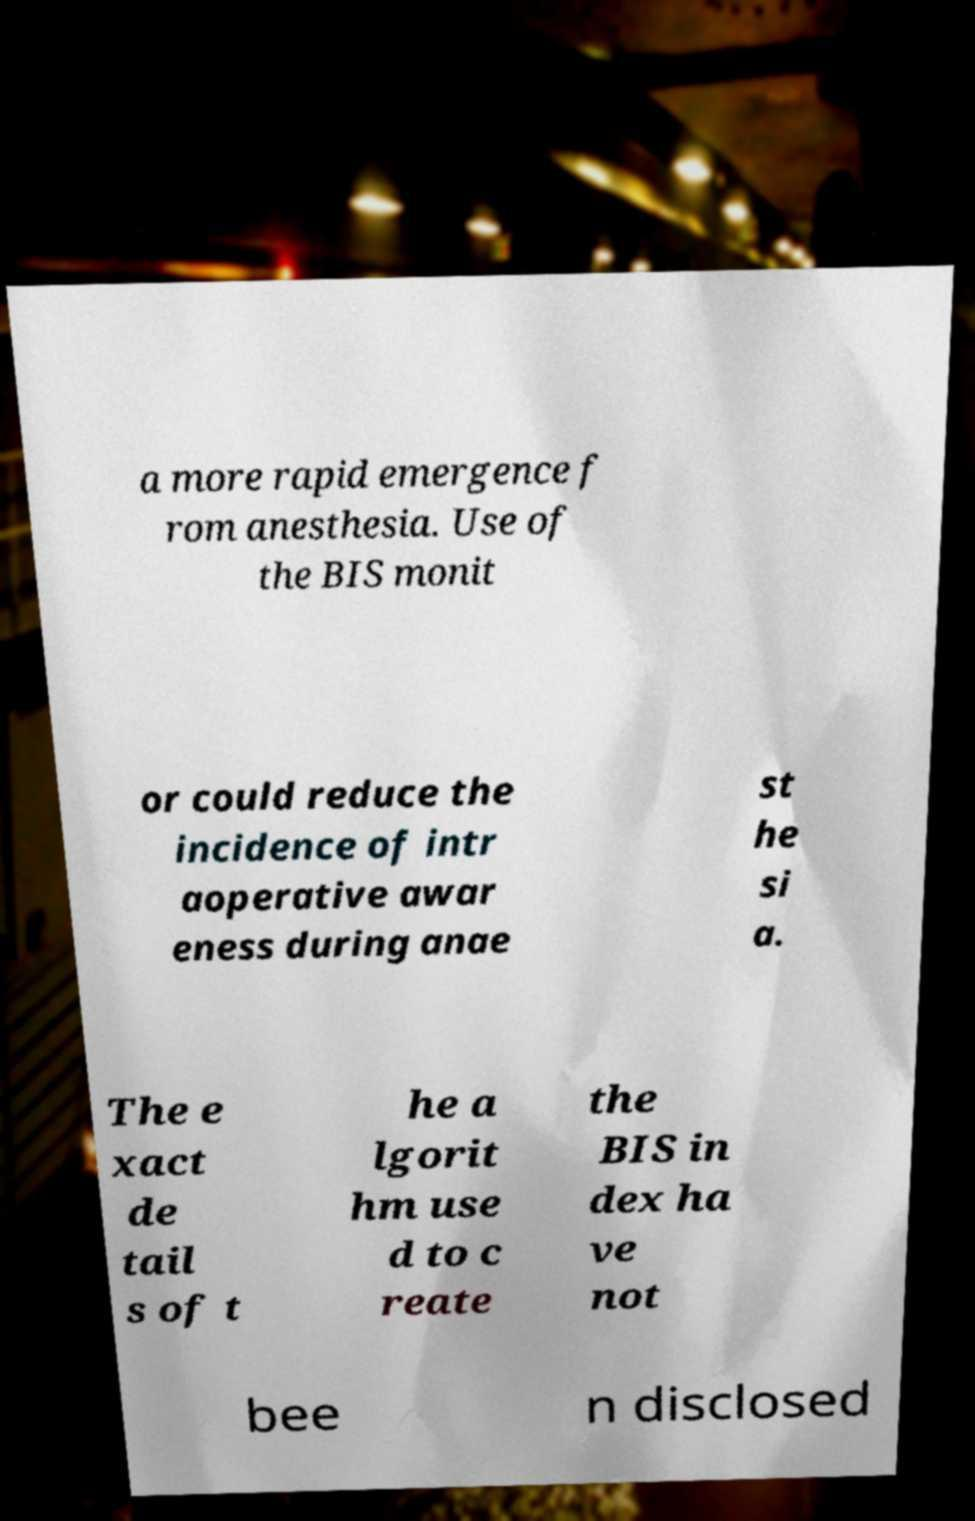What messages or text are displayed in this image? I need them in a readable, typed format. a more rapid emergence f rom anesthesia. Use of the BIS monit or could reduce the incidence of intr aoperative awar eness during anae st he si a. The e xact de tail s of t he a lgorit hm use d to c reate the BIS in dex ha ve not bee n disclosed 